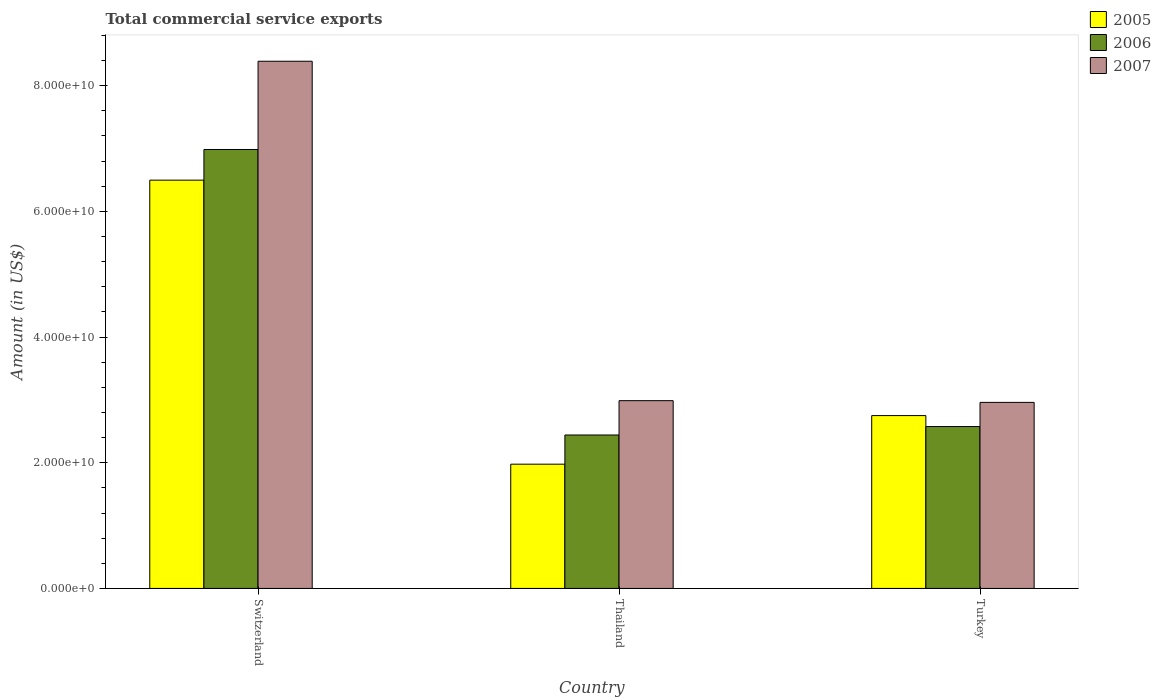How many groups of bars are there?
Give a very brief answer. 3. Are the number of bars on each tick of the X-axis equal?
Provide a short and direct response. Yes. How many bars are there on the 2nd tick from the left?
Keep it short and to the point. 3. What is the label of the 2nd group of bars from the left?
Provide a succinct answer. Thailand. What is the total commercial service exports in 2007 in Switzerland?
Make the answer very short. 8.39e+1. Across all countries, what is the maximum total commercial service exports in 2007?
Provide a succinct answer. 8.39e+1. Across all countries, what is the minimum total commercial service exports in 2007?
Your answer should be very brief. 2.96e+1. In which country was the total commercial service exports in 2005 maximum?
Your response must be concise. Switzerland. In which country was the total commercial service exports in 2005 minimum?
Make the answer very short. Thailand. What is the total total commercial service exports in 2006 in the graph?
Make the answer very short. 1.20e+11. What is the difference between the total commercial service exports in 2007 in Thailand and that in Turkey?
Ensure brevity in your answer.  2.75e+08. What is the difference between the total commercial service exports in 2005 in Thailand and the total commercial service exports in 2007 in Turkey?
Ensure brevity in your answer.  -9.83e+09. What is the average total commercial service exports in 2006 per country?
Provide a succinct answer. 4.00e+1. What is the difference between the total commercial service exports of/in 2007 and total commercial service exports of/in 2005 in Thailand?
Provide a succinct answer. 1.01e+1. In how many countries, is the total commercial service exports in 2006 greater than 84000000000 US$?
Provide a succinct answer. 0. What is the ratio of the total commercial service exports in 2006 in Switzerland to that in Thailand?
Offer a very short reply. 2.86. Is the total commercial service exports in 2006 in Switzerland less than that in Thailand?
Offer a terse response. No. What is the difference between the highest and the second highest total commercial service exports in 2006?
Provide a short and direct response. 1.34e+09. What is the difference between the highest and the lowest total commercial service exports in 2005?
Give a very brief answer. 4.52e+1. What does the 1st bar from the left in Turkey represents?
Provide a succinct answer. 2005. What does the 3rd bar from the right in Switzerland represents?
Make the answer very short. 2005. Is it the case that in every country, the sum of the total commercial service exports in 2007 and total commercial service exports in 2005 is greater than the total commercial service exports in 2006?
Offer a terse response. Yes. How many bars are there?
Give a very brief answer. 9. Are all the bars in the graph horizontal?
Your answer should be very brief. No. What is the difference between two consecutive major ticks on the Y-axis?
Provide a short and direct response. 2.00e+1. Does the graph contain any zero values?
Your response must be concise. No. Where does the legend appear in the graph?
Provide a short and direct response. Top right. How many legend labels are there?
Make the answer very short. 3. What is the title of the graph?
Give a very brief answer. Total commercial service exports. What is the label or title of the X-axis?
Your answer should be compact. Country. What is the label or title of the Y-axis?
Your response must be concise. Amount (in US$). What is the Amount (in US$) of 2005 in Switzerland?
Give a very brief answer. 6.50e+1. What is the Amount (in US$) in 2006 in Switzerland?
Your answer should be very brief. 6.98e+1. What is the Amount (in US$) of 2007 in Switzerland?
Ensure brevity in your answer.  8.39e+1. What is the Amount (in US$) in 2005 in Thailand?
Give a very brief answer. 1.98e+1. What is the Amount (in US$) in 2006 in Thailand?
Your answer should be compact. 2.44e+1. What is the Amount (in US$) of 2007 in Thailand?
Your answer should be compact. 2.99e+1. What is the Amount (in US$) in 2005 in Turkey?
Keep it short and to the point. 2.75e+1. What is the Amount (in US$) of 2006 in Turkey?
Your answer should be very brief. 2.58e+1. What is the Amount (in US$) of 2007 in Turkey?
Provide a short and direct response. 2.96e+1. Across all countries, what is the maximum Amount (in US$) of 2005?
Give a very brief answer. 6.50e+1. Across all countries, what is the maximum Amount (in US$) of 2006?
Keep it short and to the point. 6.98e+1. Across all countries, what is the maximum Amount (in US$) in 2007?
Your answer should be compact. 8.39e+1. Across all countries, what is the minimum Amount (in US$) of 2005?
Your answer should be compact. 1.98e+1. Across all countries, what is the minimum Amount (in US$) of 2006?
Give a very brief answer. 2.44e+1. Across all countries, what is the minimum Amount (in US$) of 2007?
Offer a terse response. 2.96e+1. What is the total Amount (in US$) of 2005 in the graph?
Offer a terse response. 1.12e+11. What is the total Amount (in US$) in 2006 in the graph?
Offer a terse response. 1.20e+11. What is the total Amount (in US$) of 2007 in the graph?
Offer a very short reply. 1.43e+11. What is the difference between the Amount (in US$) in 2005 in Switzerland and that in Thailand?
Offer a very short reply. 4.52e+1. What is the difference between the Amount (in US$) of 2006 in Switzerland and that in Thailand?
Give a very brief answer. 4.54e+1. What is the difference between the Amount (in US$) in 2007 in Switzerland and that in Thailand?
Provide a short and direct response. 5.40e+1. What is the difference between the Amount (in US$) in 2005 in Switzerland and that in Turkey?
Ensure brevity in your answer.  3.75e+1. What is the difference between the Amount (in US$) in 2006 in Switzerland and that in Turkey?
Offer a terse response. 4.41e+1. What is the difference between the Amount (in US$) in 2007 in Switzerland and that in Turkey?
Offer a terse response. 5.43e+1. What is the difference between the Amount (in US$) in 2005 in Thailand and that in Turkey?
Provide a short and direct response. -7.73e+09. What is the difference between the Amount (in US$) in 2006 in Thailand and that in Turkey?
Your response must be concise. -1.34e+09. What is the difference between the Amount (in US$) in 2007 in Thailand and that in Turkey?
Your answer should be compact. 2.75e+08. What is the difference between the Amount (in US$) in 2005 in Switzerland and the Amount (in US$) in 2006 in Thailand?
Your answer should be very brief. 4.05e+1. What is the difference between the Amount (in US$) in 2005 in Switzerland and the Amount (in US$) in 2007 in Thailand?
Your answer should be very brief. 3.51e+1. What is the difference between the Amount (in US$) in 2006 in Switzerland and the Amount (in US$) in 2007 in Thailand?
Offer a terse response. 4.00e+1. What is the difference between the Amount (in US$) of 2005 in Switzerland and the Amount (in US$) of 2006 in Turkey?
Ensure brevity in your answer.  3.92e+1. What is the difference between the Amount (in US$) in 2005 in Switzerland and the Amount (in US$) in 2007 in Turkey?
Provide a short and direct response. 3.54e+1. What is the difference between the Amount (in US$) in 2006 in Switzerland and the Amount (in US$) in 2007 in Turkey?
Provide a succinct answer. 4.02e+1. What is the difference between the Amount (in US$) of 2005 in Thailand and the Amount (in US$) of 2006 in Turkey?
Give a very brief answer. -5.99e+09. What is the difference between the Amount (in US$) in 2005 in Thailand and the Amount (in US$) in 2007 in Turkey?
Your answer should be very brief. -9.83e+09. What is the difference between the Amount (in US$) of 2006 in Thailand and the Amount (in US$) of 2007 in Turkey?
Give a very brief answer. -5.19e+09. What is the average Amount (in US$) of 2005 per country?
Make the answer very short. 3.74e+1. What is the average Amount (in US$) of 2006 per country?
Give a very brief answer. 4.00e+1. What is the average Amount (in US$) in 2007 per country?
Keep it short and to the point. 4.78e+1. What is the difference between the Amount (in US$) in 2005 and Amount (in US$) in 2006 in Switzerland?
Your answer should be compact. -4.88e+09. What is the difference between the Amount (in US$) of 2005 and Amount (in US$) of 2007 in Switzerland?
Your response must be concise. -1.89e+1. What is the difference between the Amount (in US$) of 2006 and Amount (in US$) of 2007 in Switzerland?
Provide a short and direct response. -1.40e+1. What is the difference between the Amount (in US$) of 2005 and Amount (in US$) of 2006 in Thailand?
Keep it short and to the point. -4.64e+09. What is the difference between the Amount (in US$) of 2005 and Amount (in US$) of 2007 in Thailand?
Ensure brevity in your answer.  -1.01e+1. What is the difference between the Amount (in US$) in 2006 and Amount (in US$) in 2007 in Thailand?
Your answer should be compact. -5.46e+09. What is the difference between the Amount (in US$) of 2005 and Amount (in US$) of 2006 in Turkey?
Provide a succinct answer. 1.75e+09. What is the difference between the Amount (in US$) of 2005 and Amount (in US$) of 2007 in Turkey?
Your answer should be very brief. -2.10e+09. What is the difference between the Amount (in US$) of 2006 and Amount (in US$) of 2007 in Turkey?
Offer a very short reply. -3.84e+09. What is the ratio of the Amount (in US$) in 2005 in Switzerland to that in Thailand?
Provide a succinct answer. 3.29. What is the ratio of the Amount (in US$) of 2006 in Switzerland to that in Thailand?
Your response must be concise. 2.86. What is the ratio of the Amount (in US$) in 2007 in Switzerland to that in Thailand?
Provide a succinct answer. 2.81. What is the ratio of the Amount (in US$) in 2005 in Switzerland to that in Turkey?
Make the answer very short. 2.36. What is the ratio of the Amount (in US$) of 2006 in Switzerland to that in Turkey?
Provide a succinct answer. 2.71. What is the ratio of the Amount (in US$) of 2007 in Switzerland to that in Turkey?
Your answer should be very brief. 2.83. What is the ratio of the Amount (in US$) in 2005 in Thailand to that in Turkey?
Your response must be concise. 0.72. What is the ratio of the Amount (in US$) of 2006 in Thailand to that in Turkey?
Your answer should be compact. 0.95. What is the ratio of the Amount (in US$) in 2007 in Thailand to that in Turkey?
Provide a succinct answer. 1.01. What is the difference between the highest and the second highest Amount (in US$) of 2005?
Provide a short and direct response. 3.75e+1. What is the difference between the highest and the second highest Amount (in US$) in 2006?
Offer a very short reply. 4.41e+1. What is the difference between the highest and the second highest Amount (in US$) of 2007?
Ensure brevity in your answer.  5.40e+1. What is the difference between the highest and the lowest Amount (in US$) of 2005?
Offer a very short reply. 4.52e+1. What is the difference between the highest and the lowest Amount (in US$) in 2006?
Give a very brief answer. 4.54e+1. What is the difference between the highest and the lowest Amount (in US$) in 2007?
Give a very brief answer. 5.43e+1. 